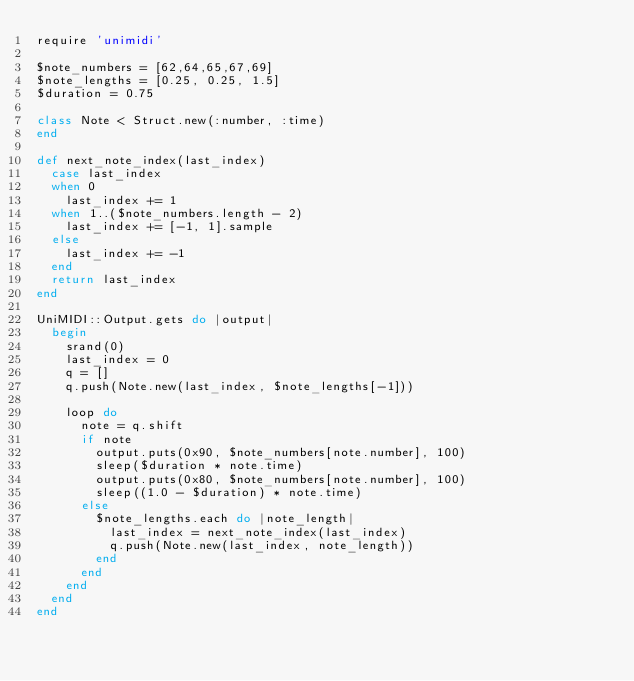Convert code to text. <code><loc_0><loc_0><loc_500><loc_500><_Ruby_>require 'unimidi'

$note_numbers = [62,64,65,67,69]
$note_lengths = [0.25, 0.25, 1.5]
$duration = 0.75

class Note < Struct.new(:number, :time)
end

def next_note_index(last_index)
  case last_index
  when 0
    last_index += 1
  when 1..($note_numbers.length - 2)
    last_index += [-1, 1].sample
  else
    last_index += -1
  end
  return last_index
end

UniMIDI::Output.gets do |output|
  begin
    srand(0)
    last_index = 0
    q = []
    q.push(Note.new(last_index, $note_lengths[-1]))

    loop do
      note = q.shift
      if note
        output.puts(0x90, $note_numbers[note.number], 100)
        sleep($duration * note.time)
        output.puts(0x80, $note_numbers[note.number], 100)
        sleep((1.0 - $duration) * note.time)
      else
        $note_lengths.each do |note_length|
          last_index = next_note_index(last_index)
          q.push(Note.new(last_index, note_length))
        end
      end
    end
  end
end
</code> 